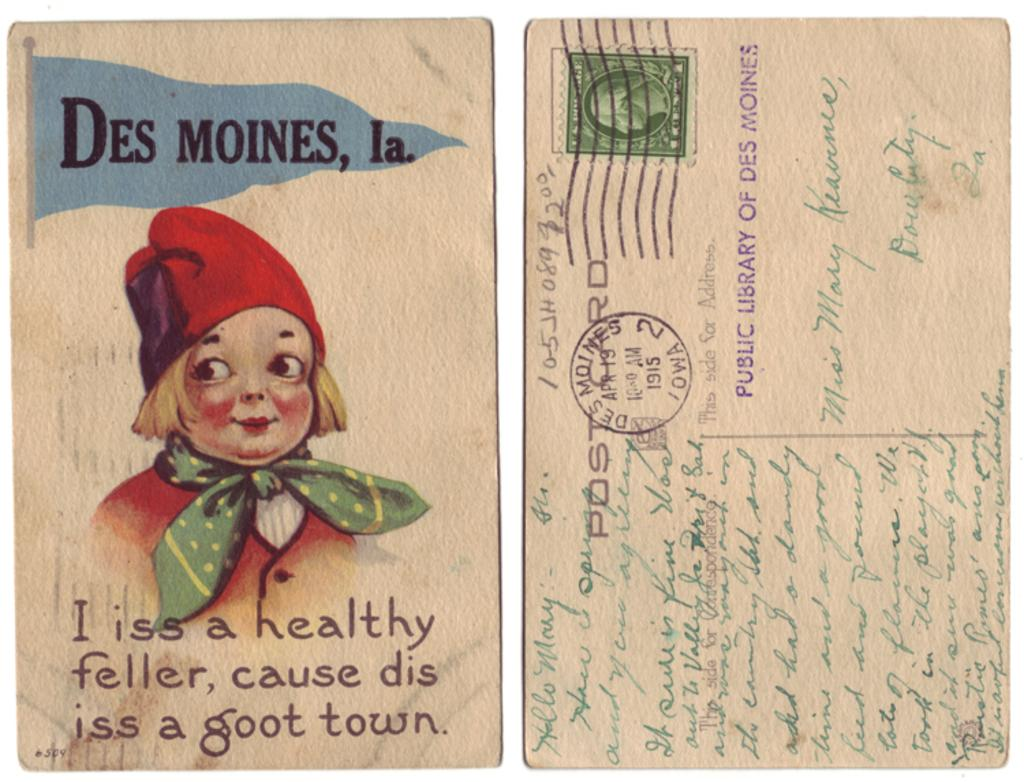What is present on the paper in the image? There is a picture and text on the paper in the image. Can you describe the picture on the paper? Unfortunately, the specific details of the picture cannot be determined from the provided facts. What type of information is conveyed by the text on the paper? The nature of the text cannot be determined from the provided facts. How does the grandmother help the secretary find the way in the image? There is no grandmother, secretary, or indication of a way in the image; it only features a paper with a picture and text. 